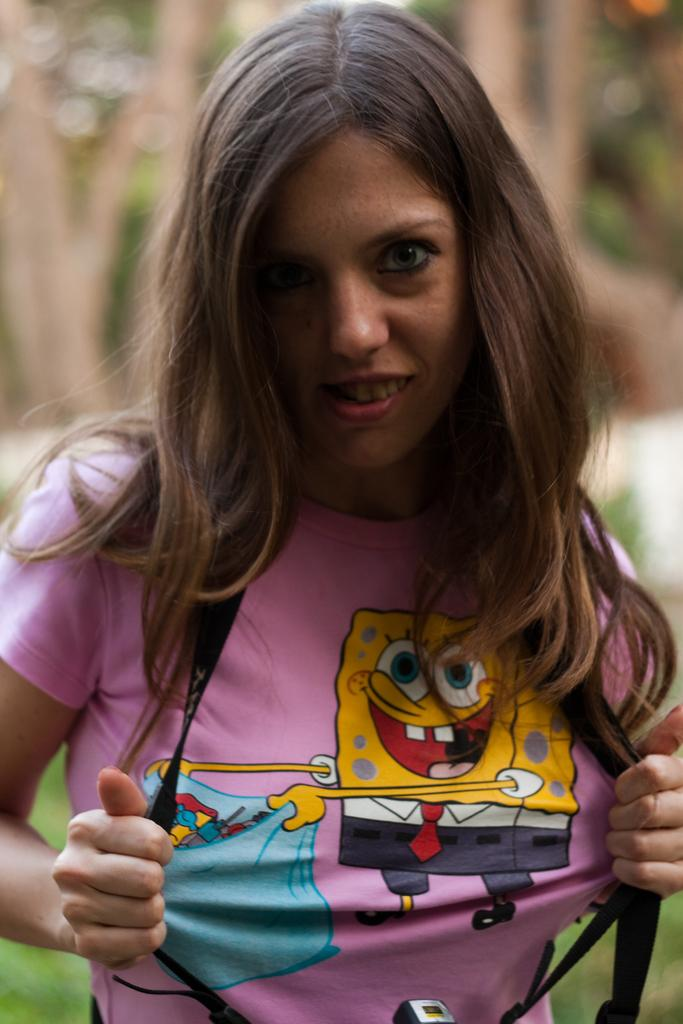Who is present in the image? There is a woman in the image. What can be seen in the background of the image? There are trees in the background of the image. How many snails are crawling on the calendar in the image? There is no calendar or snails present in the image. 